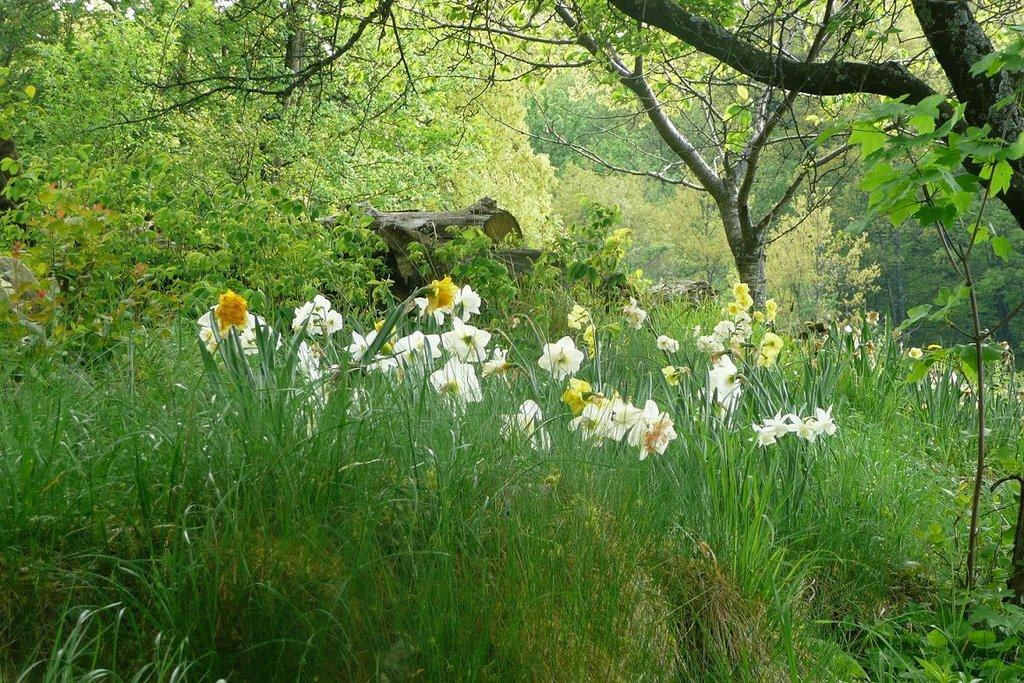What type of vegetation is at the bottom of the image? There is grass at the bottom of the image. What other types of plants can be seen in the image? There are flowers in the image. What can be seen in the distance in the image? There are trees in the background of the image. What color is the sweater worn by the cart in the image? There is no cart or sweater present in the image. 